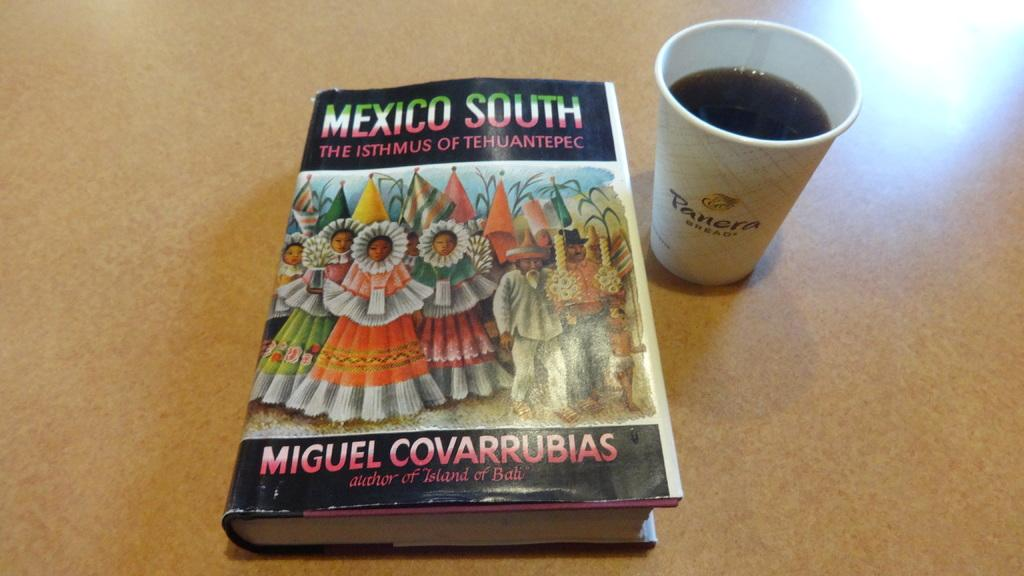Provide a one-sentence caption for the provided image. A textbook titled Mexico South the Isthmus of Tehuantepec. 